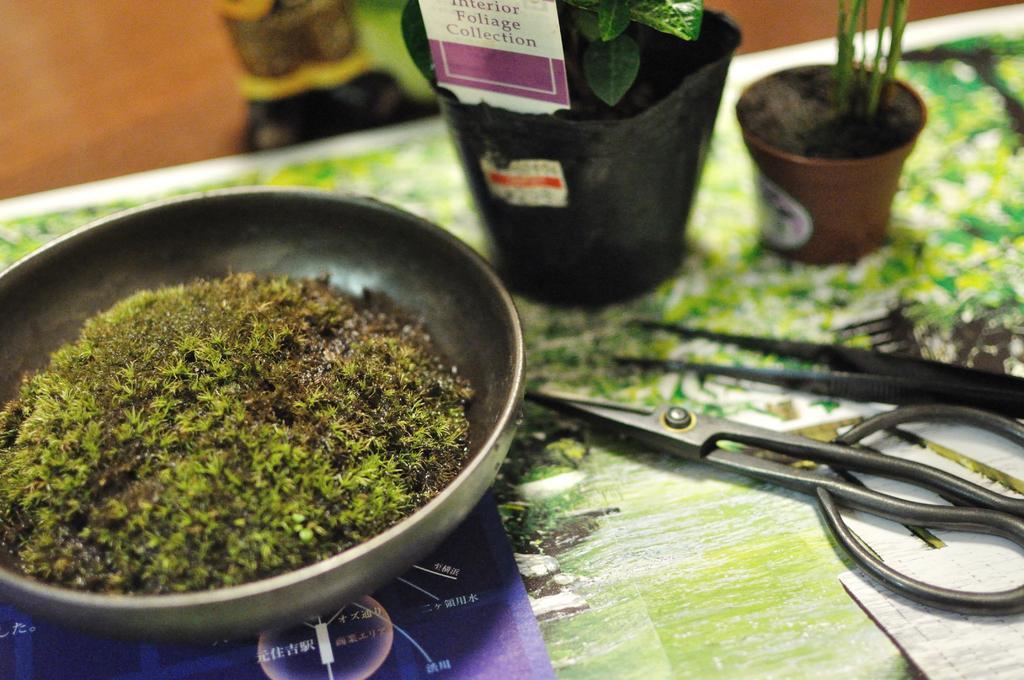How would you summarize this image in a sentence or two? In this image there is a table and we can see a scissor, cutter, houseplants and a vessel containing moss placed on the table. In the background there is a wall and we can see an object. 